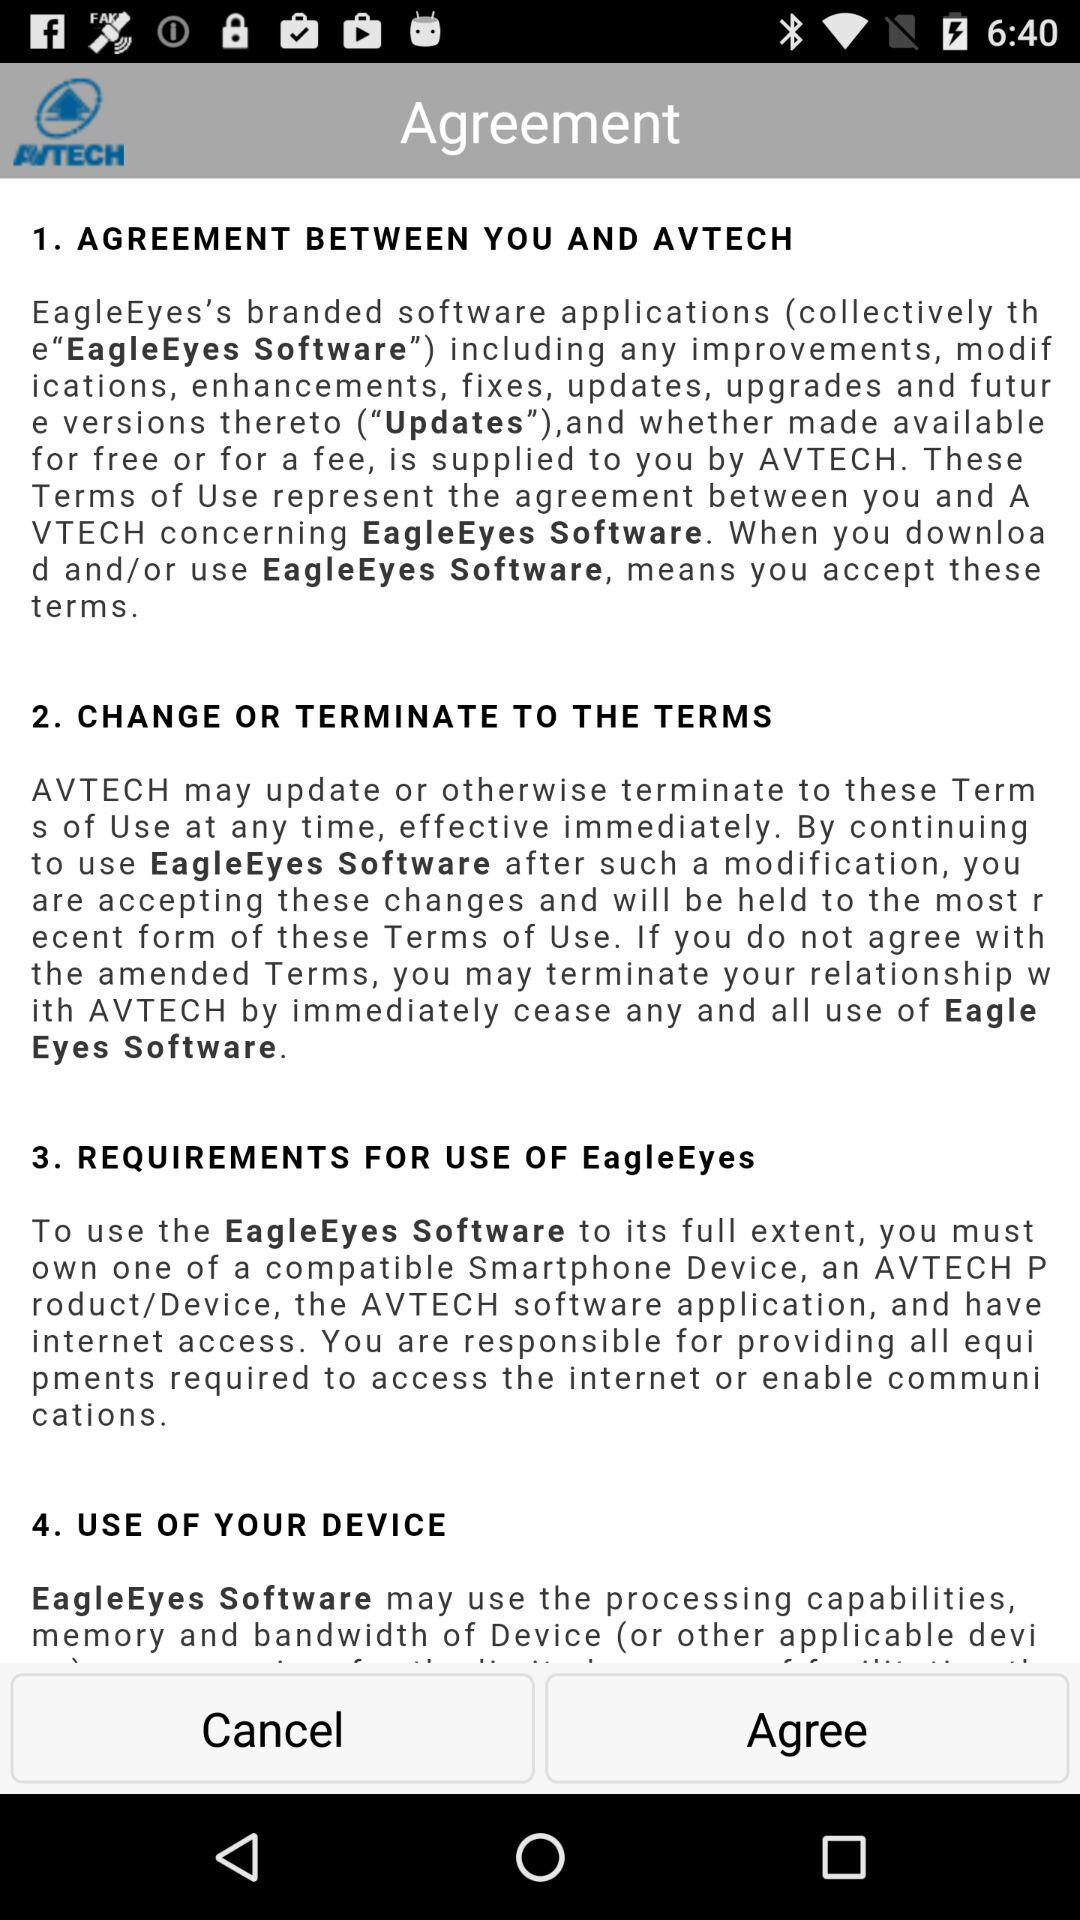How many sections are there in the terms of use?
Answer the question using a single word or phrase. 4 